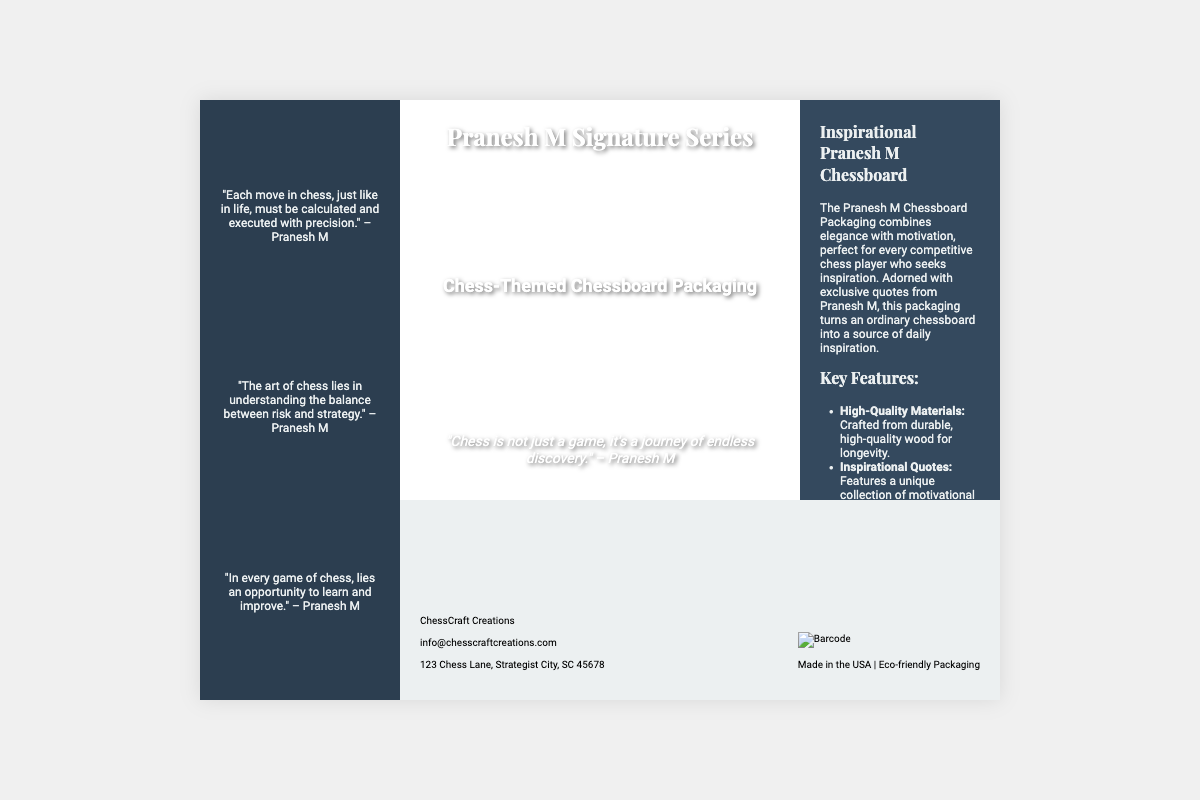What is the main title of the product? The main title is prominently displayed in the front cover of the packaging as "Pranesh M Signature Series".
Answer: Pranesh M Signature Series What is the background color of the front cover? The background color of the front cover is primarily white, with other elements layered on top.
Answer: White How many key features are listed in the back panel? The back panel lists four key features of the product.
Answer: Four What quote is featured on the front cover? The front cover includes a quote from Pranesh M which emphasizes the journey of chess.
Answer: "Chess is not just a game, it's a journey of endless discovery." What is the name of the company that produced this packaging? The company's name is displayed in the bottom panel of the packaging.
Answer: ChessCraft Creations What type of design is the chessboard described as having? The description in the back panel highlights the chessboard's design as "sleek and sophisticated".
Answer: Sleek and sophisticated What is the purpose of the quotes included in the packaging? The quotes are intended to provide motivation and inspiration for chess players.
Answer: Motivation and inspiration What type of material is the chessboard made from? The back panel mentions that the chessboard is crafted from "durable, high-quality wood".
Answer: High-quality wood 